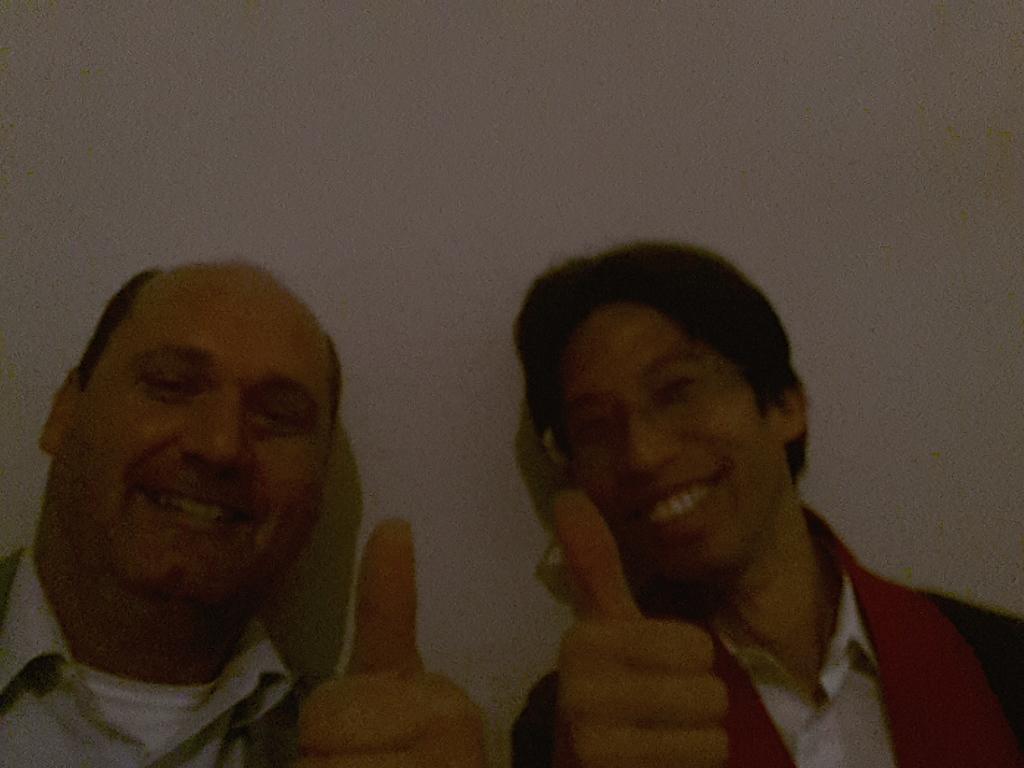Could you give a brief overview of what you see in this image? In the foreground of this picture, there are men showing thumbs up to the camera. In the background, there is a wall. 